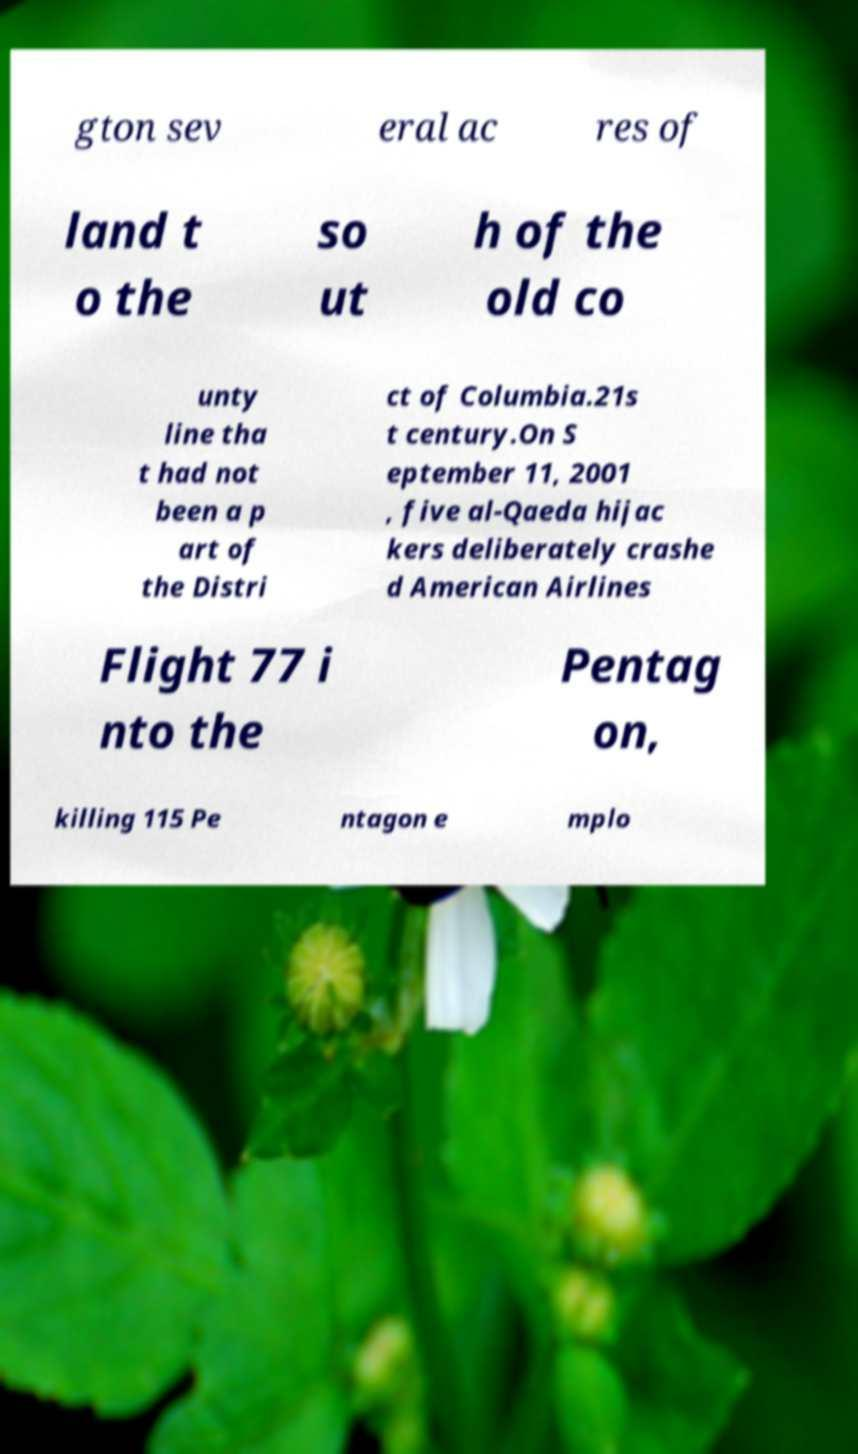I need the written content from this picture converted into text. Can you do that? gton sev eral ac res of land t o the so ut h of the old co unty line tha t had not been a p art of the Distri ct of Columbia.21s t century.On S eptember 11, 2001 , five al-Qaeda hijac kers deliberately crashe d American Airlines Flight 77 i nto the Pentag on, killing 115 Pe ntagon e mplo 